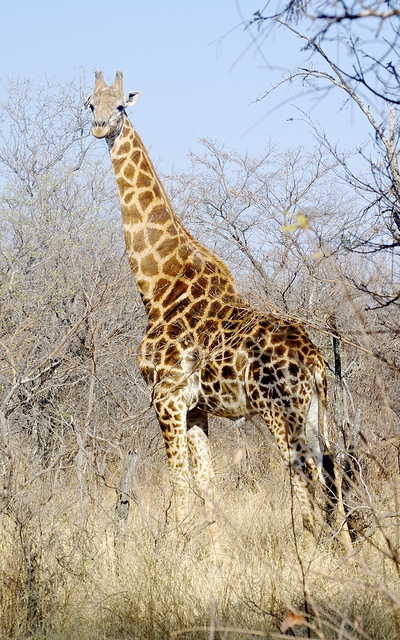Describe the objects in this image and their specific colors. I can see a giraffe in lightblue, tan, maroon, and ivory tones in this image. 